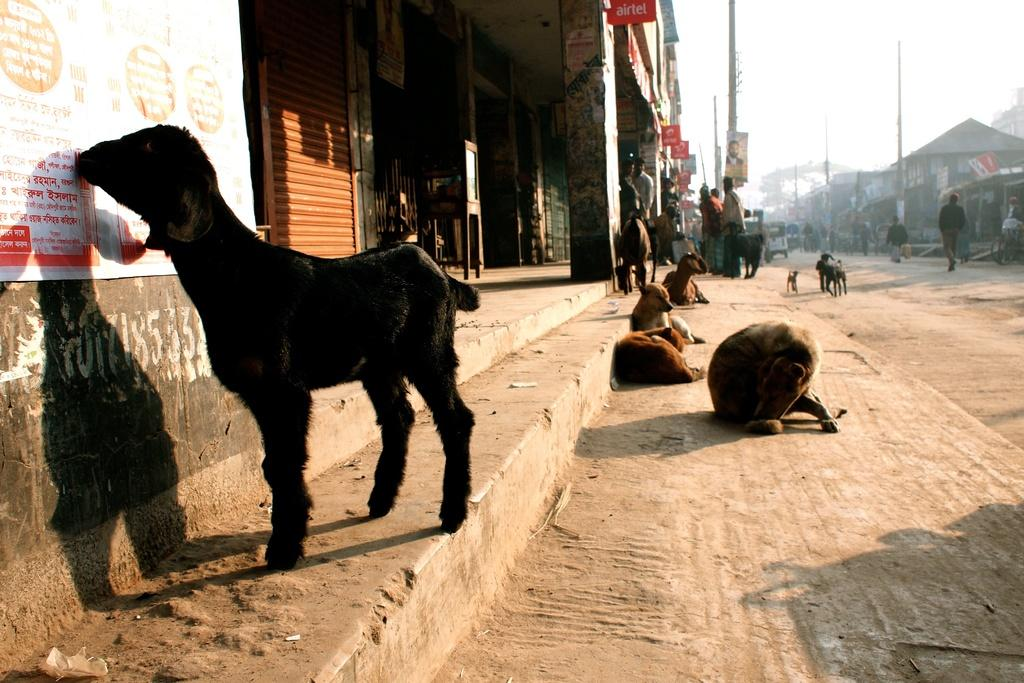What types of living organisms can be seen in the image? There are animals and people in the image. What can be seen in the background of the image? There are poles, buildings, and the sky visible in the background of the image. What are the boards attached to in the image? The boards are attached to pillars and poles in the image. What type of cheese is being crushed by the front tire of the car in the image? There is no car or cheese present in the image. 